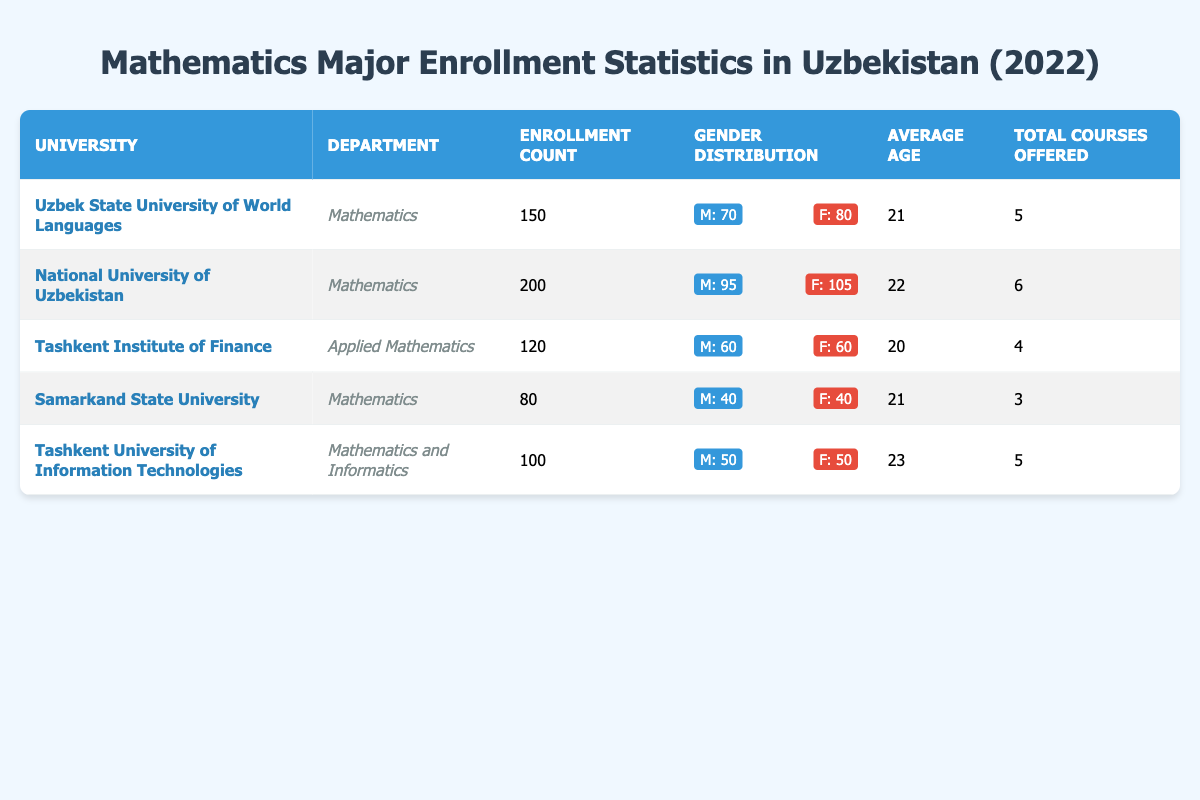What is the enrollment count at the National University of Uzbekistan? The table shows that the enrollment count for the National University of Uzbekistan is listed as 200.
Answer: 200 Which university has the highest number of female students enrolled? By examining the gender distribution for each university, the National University of Uzbekistan has 105 females, which is higher than any other university's female enrollment.
Answer: National University of Uzbekistan What is the average age of students at the Tashkent Institute of Finance? The table indicates that the average age of students enrolled at the Tashkent Institute of Finance is 20.
Answer: 20 How many total courses are offered by Samarkand State University? The table specifies that Samarkand State University offers a total of 3 courses.
Answer: 3 What is the total enrollment count for all universities listed? By adding up the enrollment counts (150 + 200 + 120 + 80 + 100), the total comes to 650.
Answer: 650 Which university has the lowest enrollment count among the listed universities? Comparing the enrollment counts, Samarkand State University has the lowest count at 80 students.
Answer: Samarkand State University What is the difference in enrollment count between Uzbek State University of World Languages and Tashkent University of Information Technologies? The enrollment counts are 150 and 100, respectively. Subtracting gives 150 - 100 = 50.
Answer: 50 Is the average age of students at Tashkent University of Information Technologies higher than that at Samarkand State University? The average age for Tashkent University is 23, while for Samarkand State University, it is 21. Since 23 is greater than 21, the statement is true.
Answer: Yes What percentage of the total enrollment at the National University of Uzbekistan are male students? The total male students at the National University of Uzbekistan is 95 out of 200 total students. Calculating the percentage gives (95/200) * 100 = 47.5%.
Answer: 47.5% If we consider only the enrollment counts for Mathematics departments, which university has the highest enrollment? The enrollment counts for Mathematics departments are 150 for Uzbek State University, 200 for National University of Uzbekistan, and 80 for Samarkand State University. The highest is 200.
Answer: National University of Uzbekistan 